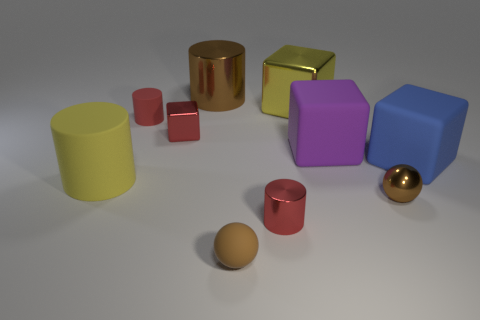Subtract 1 cylinders. How many cylinders are left? 3 Subtract all brown cubes. Subtract all cyan cylinders. How many cubes are left? 4 Subtract all spheres. How many objects are left? 8 Add 3 large yellow metal things. How many large yellow metal things exist? 4 Subtract 1 yellow cubes. How many objects are left? 9 Subtract all large purple cubes. Subtract all purple shiny cylinders. How many objects are left? 9 Add 6 large yellow things. How many large yellow things are left? 8 